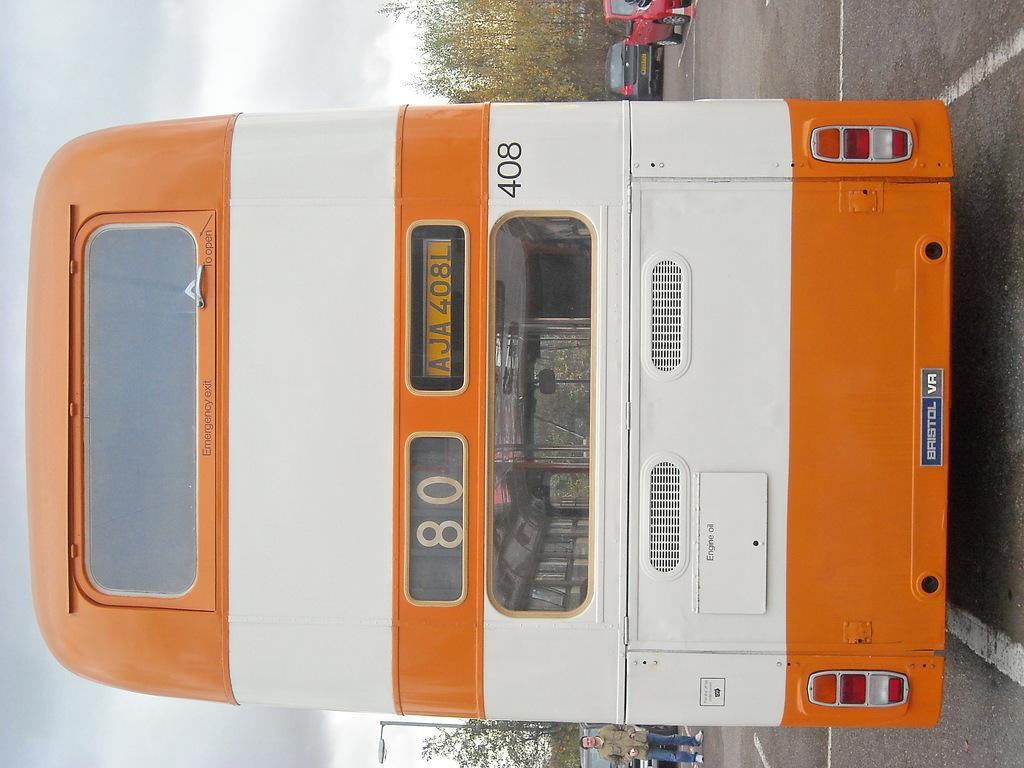Describe this image in one or two sentences. In this image I can see few vehicles around. In front I can see vehicle which is in orange and white color. Back I can see a person,trees,and light pole. The sky is in white and ash color. 